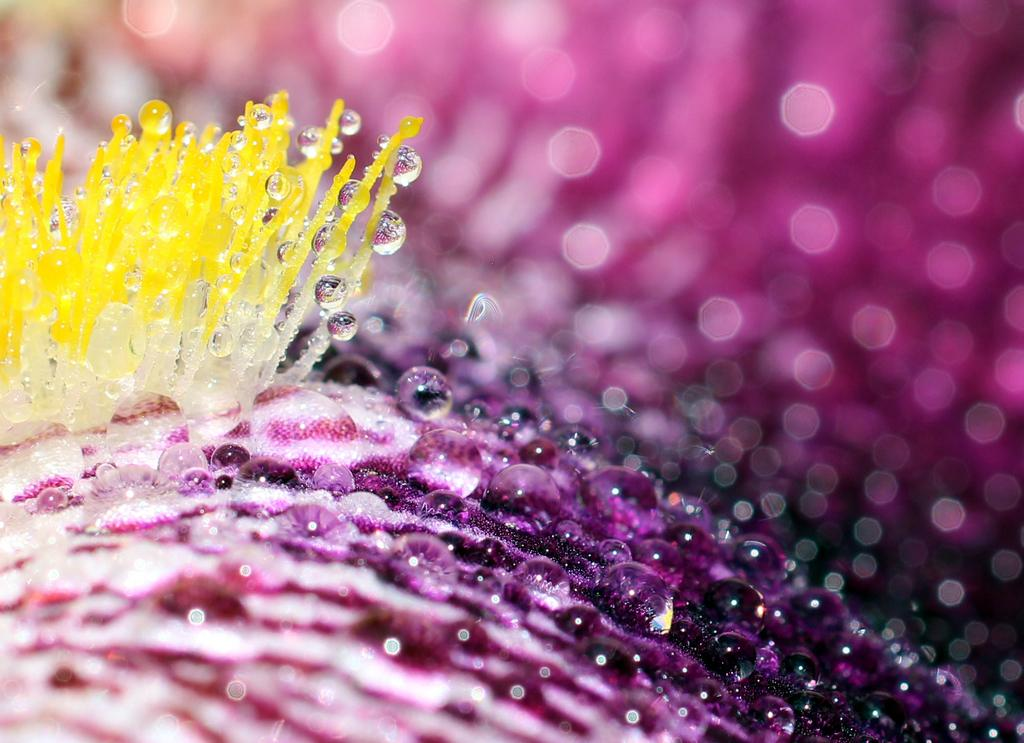What is the main subject of the image? There is a flower in the image. Where is the flower located in the image? The flower is in the front of the image. What can be observed on the surface of the flower? The flower has many water droplets on it. What type of harmony is being expressed through the statement made by the flower in the image? There is no statement being made by the flower in the image, nor is there any indication of harmony. 